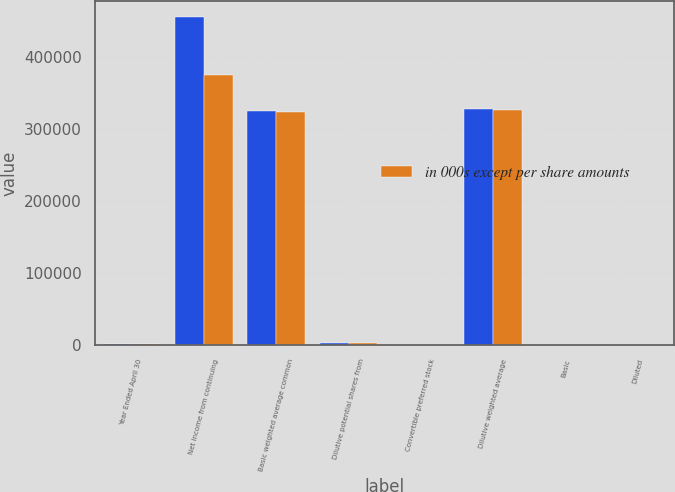<chart> <loc_0><loc_0><loc_500><loc_500><stacked_bar_chart><ecel><fcel>Year Ended April 30<fcel>Net income from continuing<fcel>Basic weighted average common<fcel>Dilutive potential shares from<fcel>Convertible preferred stock<fcel>Dilutive weighted average<fcel>Basic<fcel>Diluted<nl><fcel>nan<fcel>2008<fcel>454476<fcel>324810<fcel>2656<fcel>2<fcel>327468<fcel>1.4<fcel>1.39<nl><fcel>in 000s except per share amounts<fcel>2007<fcel>374337<fcel>322688<fcel>3464<fcel>2<fcel>326154<fcel>1.16<fcel>1.15<nl></chart> 